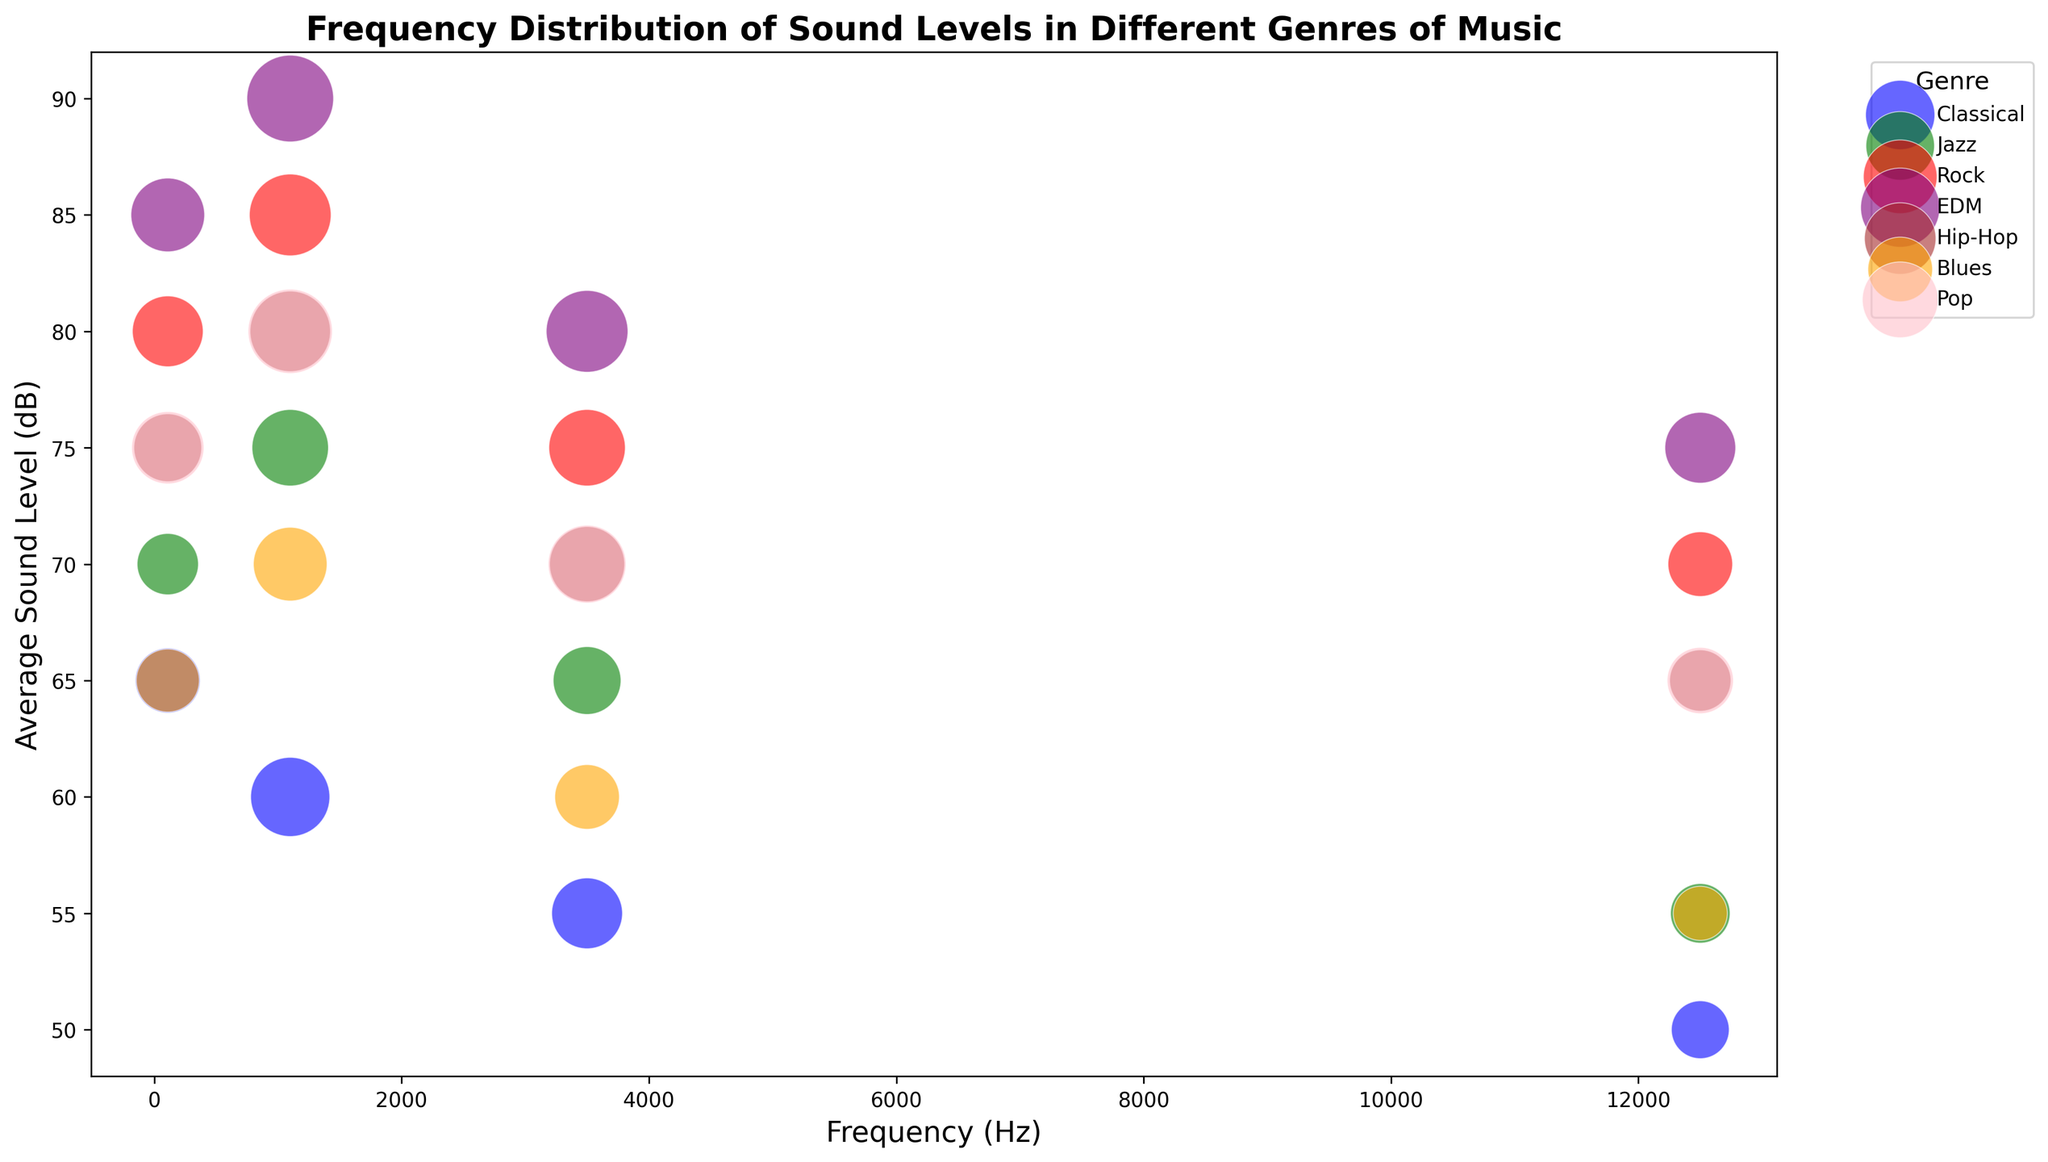What genre has the highest average sound level in the 5000-20000 Hz frequency range? Locate the 5000-20000 Hz frequency range on the x-axis. Among the bubbles positioned in this range, find the one with the highest position on the y-axis. The rock genre has a bubble at 70 dB, which is the highest average sound level.
Answer: Rock Which genre has the largest number of samples in the 200-2000 Hz frequency range? Focus on the bubbles within the 200-2000 Hz frequency range. Compare the sizes of these bubbles to determine which is the largest. The EDM genre has the largest bubble, indicating the highest number of samples at 180.
Answer: EDM What is the difference in average sound levels between Classical and Rock music in the 20-200 Hz frequency range? Locate the 20-200 Hz bubbles for Classical and Rock. The Classical bubble is at 65 dB, and the Rock bubble is at 80 dB. Subtract the sound levels: 80 - 65 = 15.
Answer: 15 dB Which genre generally has the lowest average sound levels across all frequency ranges? Observe the position of bubbles on the y-axis across all frequency ranges. The Classical genre consistently has the lowest positioned bubbles, indicating lower average sound levels.
Answer: Classical Which genre exhibits the largest spread in average sound levels across different frequency ranges? Compare how much the y-axis values change for each genre across all frequency ranges. The EDM genre spans from 75 dB to 90 dB, which is a spread of 15 dB, the largest among the genres.
Answer: EDM What is the sum of average sound levels for Jazz music across all frequency ranges? Gather the average sound levels for Jazz in all frequency ranges: 70 dB, 75 dB, 65 dB, and 55 dB. Add these values: 70 + 75 + 65 + 55 = 265.
Answer: 265 dB Which genre has the highest average sound level in the 2000-5000 Hz frequency range? Identify the 2000-5000 Hz frequency range and locate the highest bubble on the y-axis within this range. The EDM genre has a bubble at 80 dB, the highest in this frequency range.
Answer: EDM How does the number of samples for Pop in the 5000-20000 Hz frequency range compare to Jazz in the same range? Locate the bubbles for Pop and Jazz in the 5000-20000 Hz range. The Pop bubble corresponds to 105 samples, whereas the Jazz bubble corresponds to 85 samples. Comparing these, Pop has 20 more samples.
Answer: Pop has 20 more samples What is the trend in average sound levels across frequency ranges for Hip-Hop music? Observe the y-axis positions of Hip-Hop bubbles across frequency ranges: starting from 75 dB in 20-200 Hz, rising to 80 dB in 200-2000 Hz, then dropping to 70 dB in 2000-5000 Hz, and further dropping to 65 dB in 5000-20000 Hz. The trend shows an initial rise followed by a consistent decline.
Answer: Rise then decline Which genre has the smallest bubble in the 20-200 Hz frequency range, and what does this indicate? Look at the bubbles in the 20-200 Hz range and identify the smallest one. The Blues genre has the smallest bubble, indicating the least number of samples at 95.
Answer: Blues, least samples 